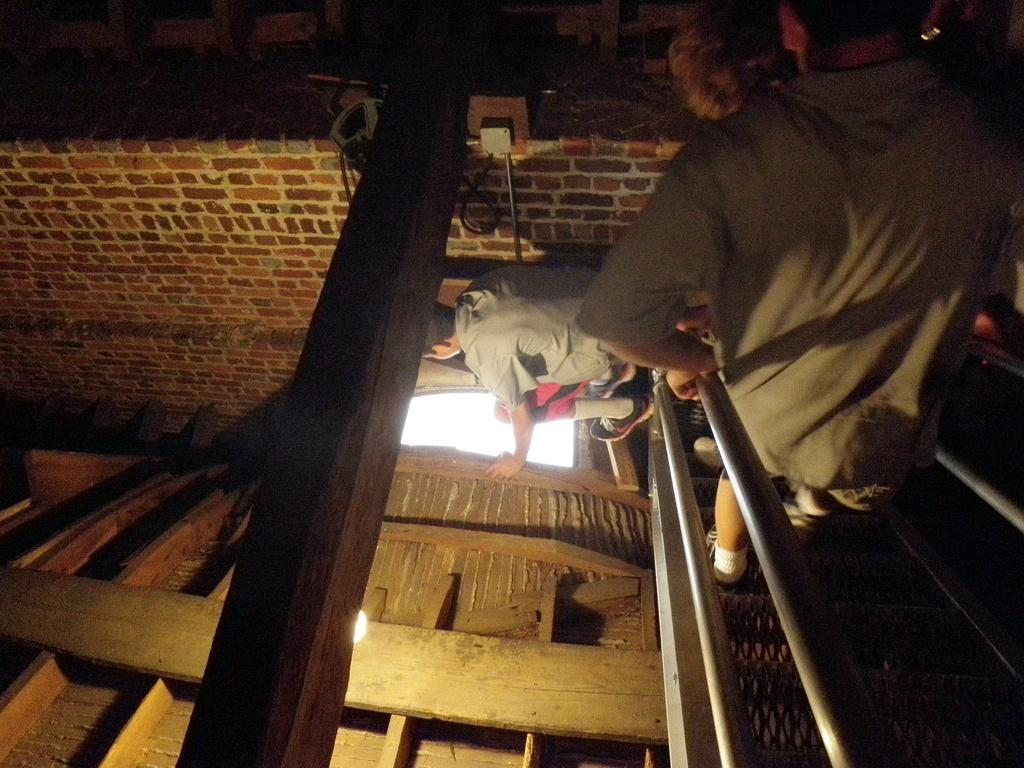How many people are in the image? There are two people in the image. What are the people wearing on their upper bodies? Both people are wearing t-shirts. What type of footwear are the people wearing? Both people are wearing shoes. Can you describe the lighting in the image? There is light in the image, but it appears to be slightly dark. What type of sound can be heard coming from the gate in the image? There is no gate present in the image, so it is not possible to determine what, if any, sound might be heard. 